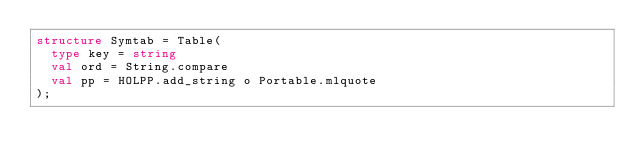<code> <loc_0><loc_0><loc_500><loc_500><_SML_>structure Symtab = Table(
  type key = string
  val ord = String.compare
  val pp = HOLPP.add_string o Portable.mlquote
);
</code> 